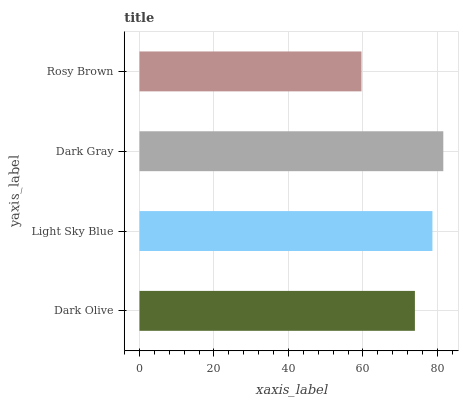Is Rosy Brown the minimum?
Answer yes or no. Yes. Is Dark Gray the maximum?
Answer yes or no. Yes. Is Light Sky Blue the minimum?
Answer yes or no. No. Is Light Sky Blue the maximum?
Answer yes or no. No. Is Light Sky Blue greater than Dark Olive?
Answer yes or no. Yes. Is Dark Olive less than Light Sky Blue?
Answer yes or no. Yes. Is Dark Olive greater than Light Sky Blue?
Answer yes or no. No. Is Light Sky Blue less than Dark Olive?
Answer yes or no. No. Is Light Sky Blue the high median?
Answer yes or no. Yes. Is Dark Olive the low median?
Answer yes or no. Yes. Is Dark Olive the high median?
Answer yes or no. No. Is Dark Gray the low median?
Answer yes or no. No. 